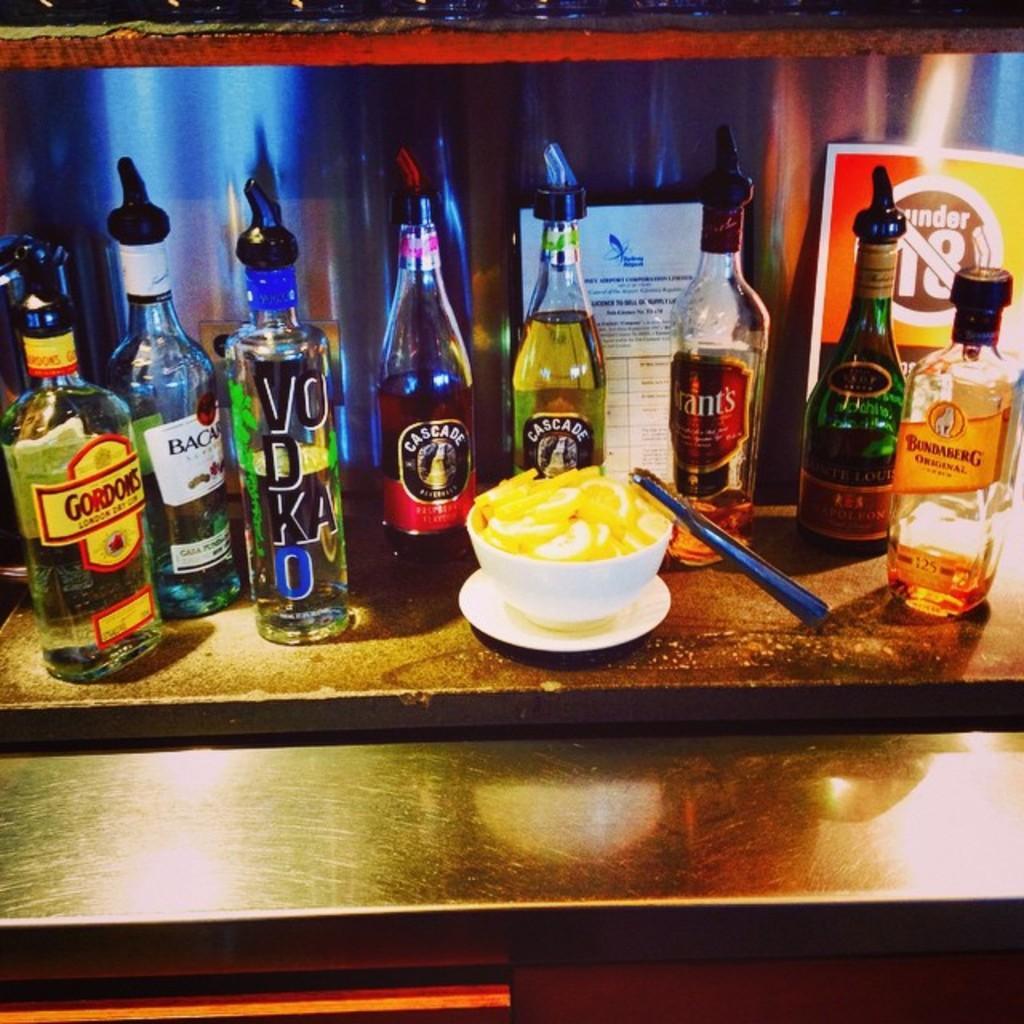Describe this image in one or two sentences. In the image there is a table. On table we can see few bottles on which it is labelled as 'VODKA' and there is also a bowl with some food and a plate. 